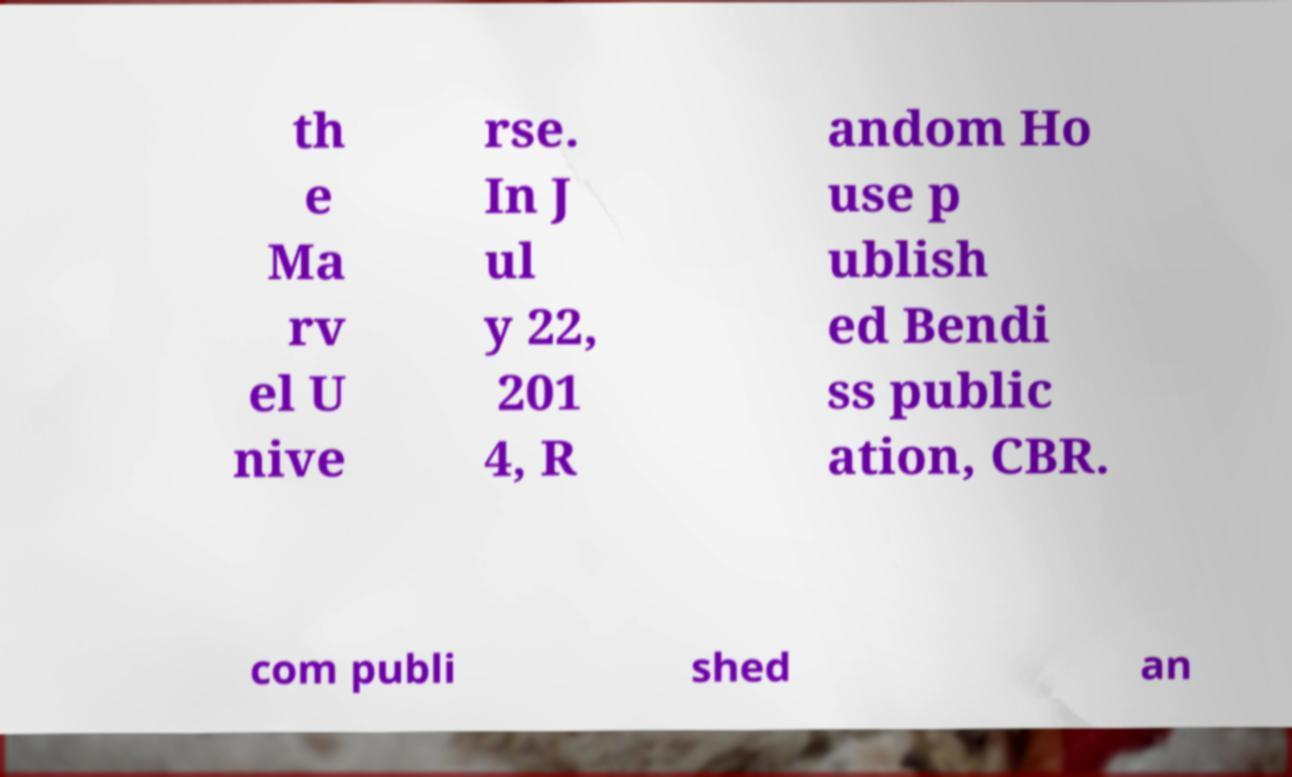There's text embedded in this image that I need extracted. Can you transcribe it verbatim? th e Ma rv el U nive rse. In J ul y 22, 201 4, R andom Ho use p ublish ed Bendi ss public ation, CBR. com publi shed an 